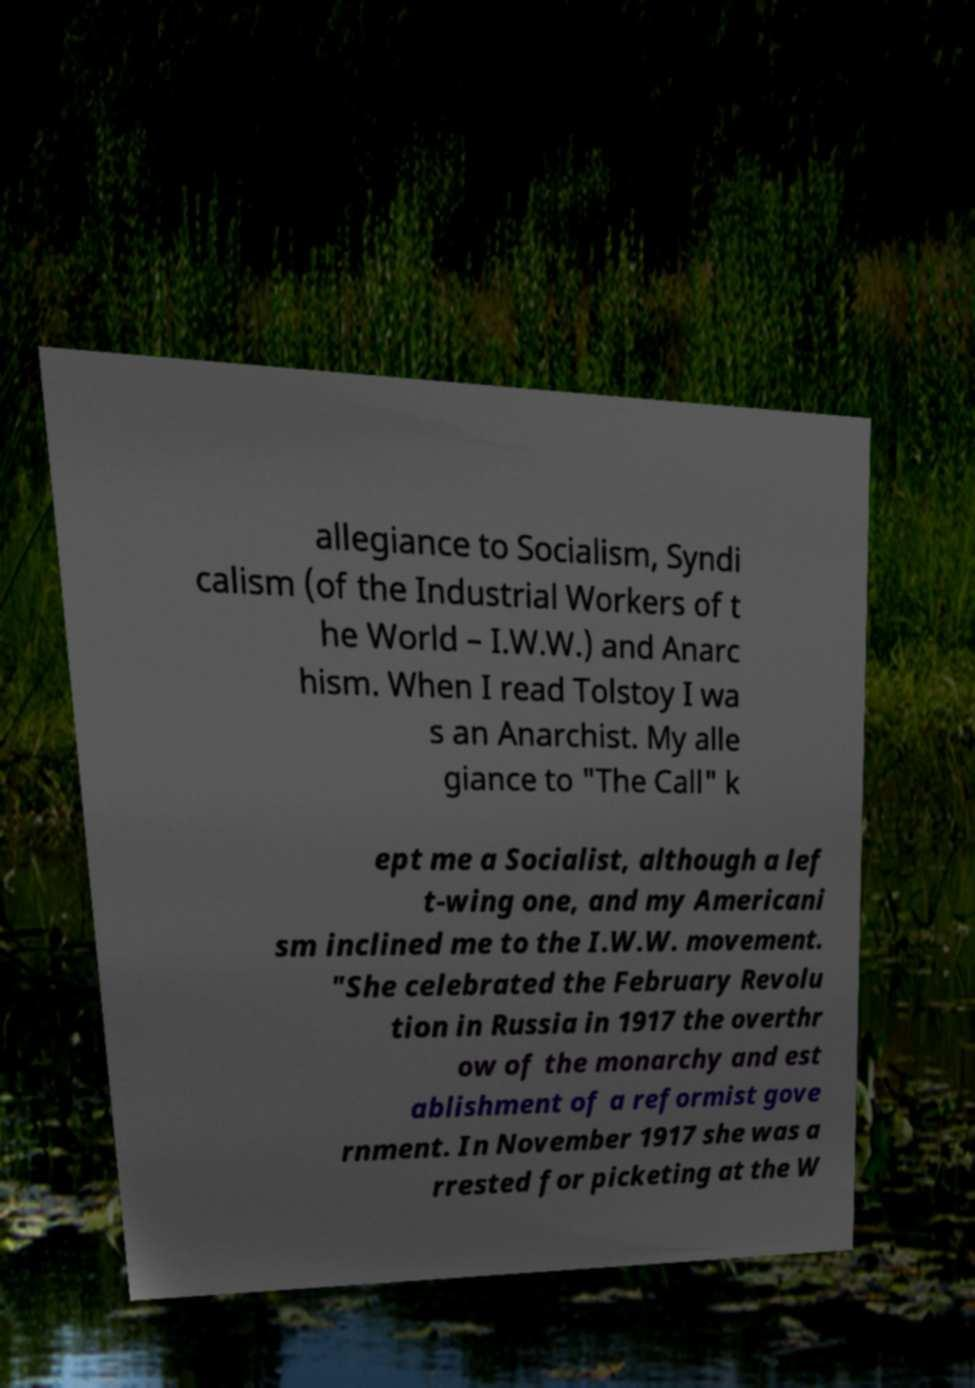Could you assist in decoding the text presented in this image and type it out clearly? allegiance to Socialism, Syndi calism (of the Industrial Workers of t he World – I.W.W.) and Anarc hism. When I read Tolstoy I wa s an Anarchist. My alle giance to "The Call" k ept me a Socialist, although a lef t-wing one, and my Americani sm inclined me to the I.W.W. movement. "She celebrated the February Revolu tion in Russia in 1917 the overthr ow of the monarchy and est ablishment of a reformist gove rnment. In November 1917 she was a rrested for picketing at the W 